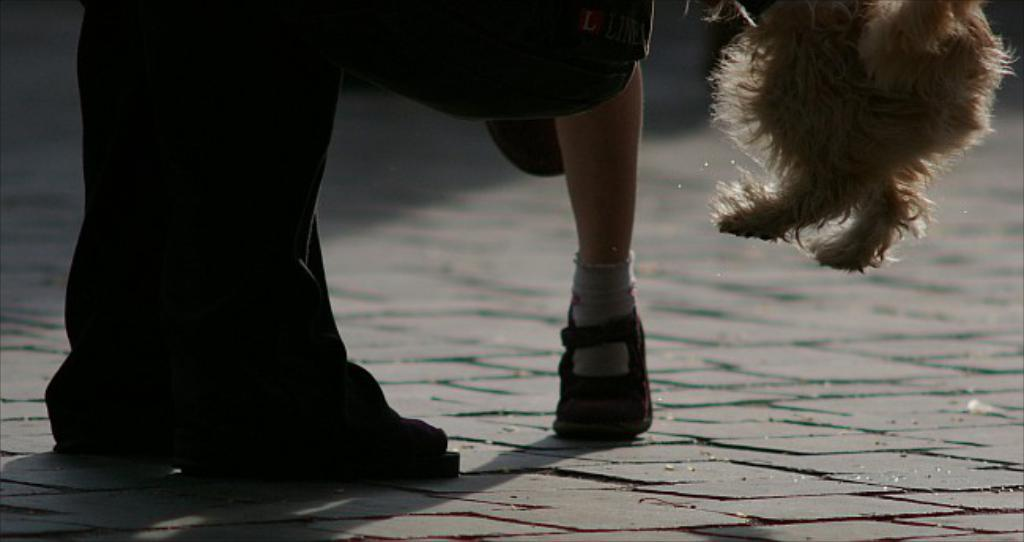How many people are in the image? There are two persons in the image. What other living creature is present in the image? There is a dog in the image. Where was the image taken? The image is taken on a road. Can you determine the time of day the image was taken? The image is likely taken during the day, as there is sufficient light. What type of flowers can be seen growing on the tramp in the image? There is no tramp or flowers present in the image. 